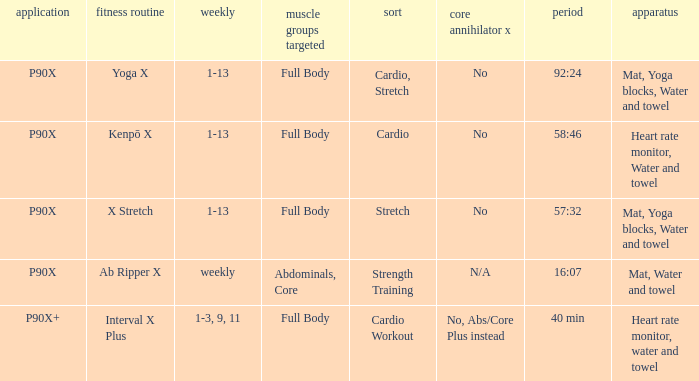What is the ab ripper x when the length is 92:24? No. Can you give me this table as a dict? {'header': ['application', 'fitness routine', 'weekly', 'muscle groups targeted', 'sort', 'core annihilator x', 'period', 'apparatus'], 'rows': [['P90X', 'Yoga X', '1-13', 'Full Body', 'Cardio, Stretch', 'No', '92:24', 'Mat, Yoga blocks, Water and towel'], ['P90X', 'Kenpō X', '1-13', 'Full Body', 'Cardio', 'No', '58:46', 'Heart rate monitor, Water and towel'], ['P90X', 'X Stretch', '1-13', 'Full Body', 'Stretch', 'No', '57:32', 'Mat, Yoga blocks, Water and towel'], ['P90X', 'Ab Ripper X', 'weekly', 'Abdominals, Core', 'Strength Training', 'N/A', '16:07', 'Mat, Water and towel'], ['P90X+', 'Interval X Plus', '1-3, 9, 11', 'Full Body', 'Cardio Workout', 'No, Abs/Core Plus instead', '40 min', 'Heart rate monitor, water and towel']]} 